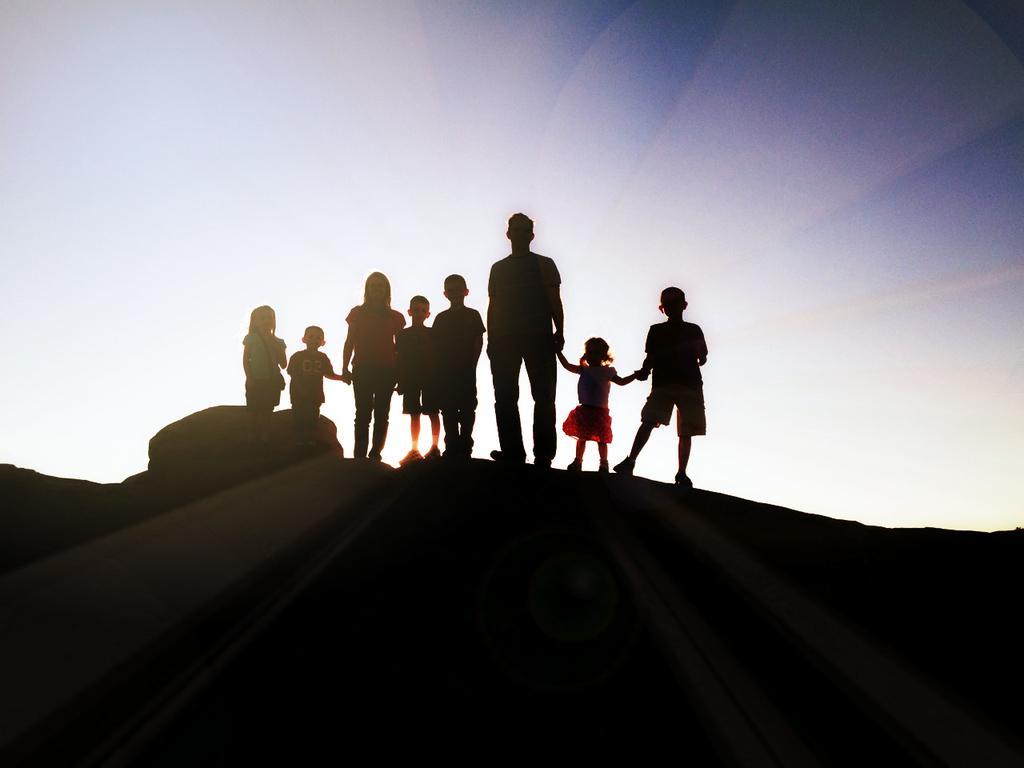Could you give a brief overview of what you see in this image? In this image, I can see a group of people standing on a rock. In the background, there is the sky. 